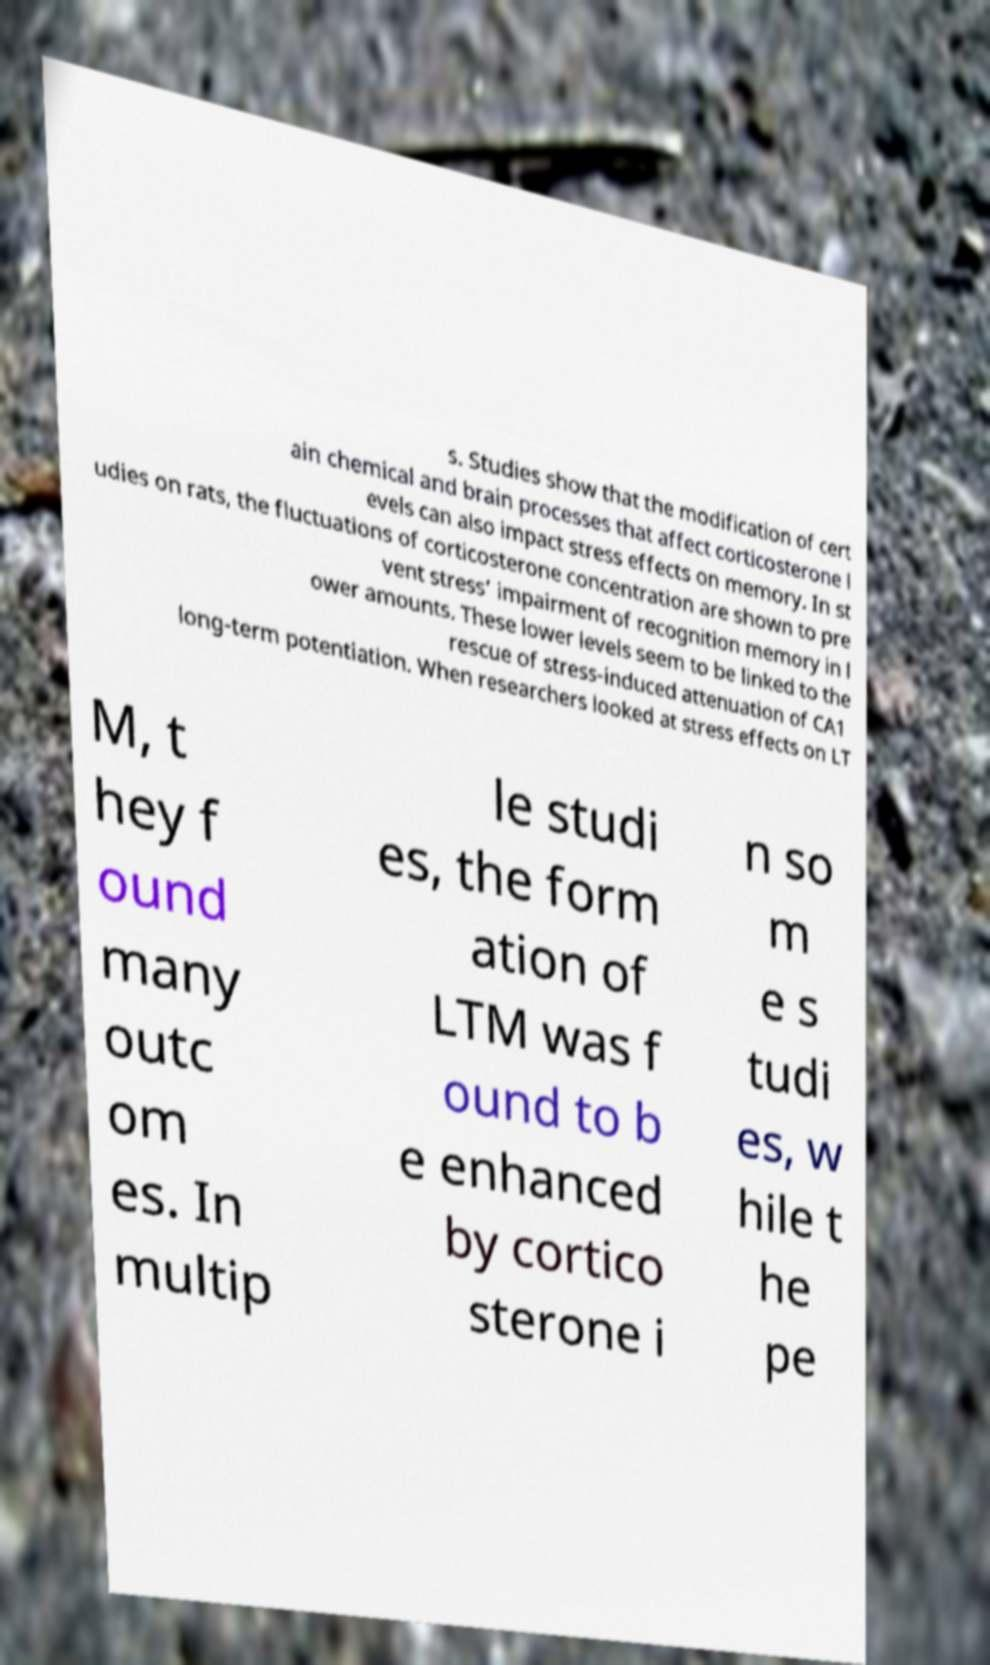Could you extract and type out the text from this image? s. Studies show that the modification of cert ain chemical and brain processes that affect corticosterone l evels can also impact stress effects on memory. In st udies on rats, the fluctuations of corticosterone concentration are shown to pre vent stress’ impairment of recognition memory in l ower amounts. These lower levels seem to be linked to the rescue of stress-induced attenuation of CA1 long-term potentiation. When researchers looked at stress effects on LT M, t hey f ound many outc om es. In multip le studi es, the form ation of LTM was f ound to b e enhanced by cortico sterone i n so m e s tudi es, w hile t he pe 